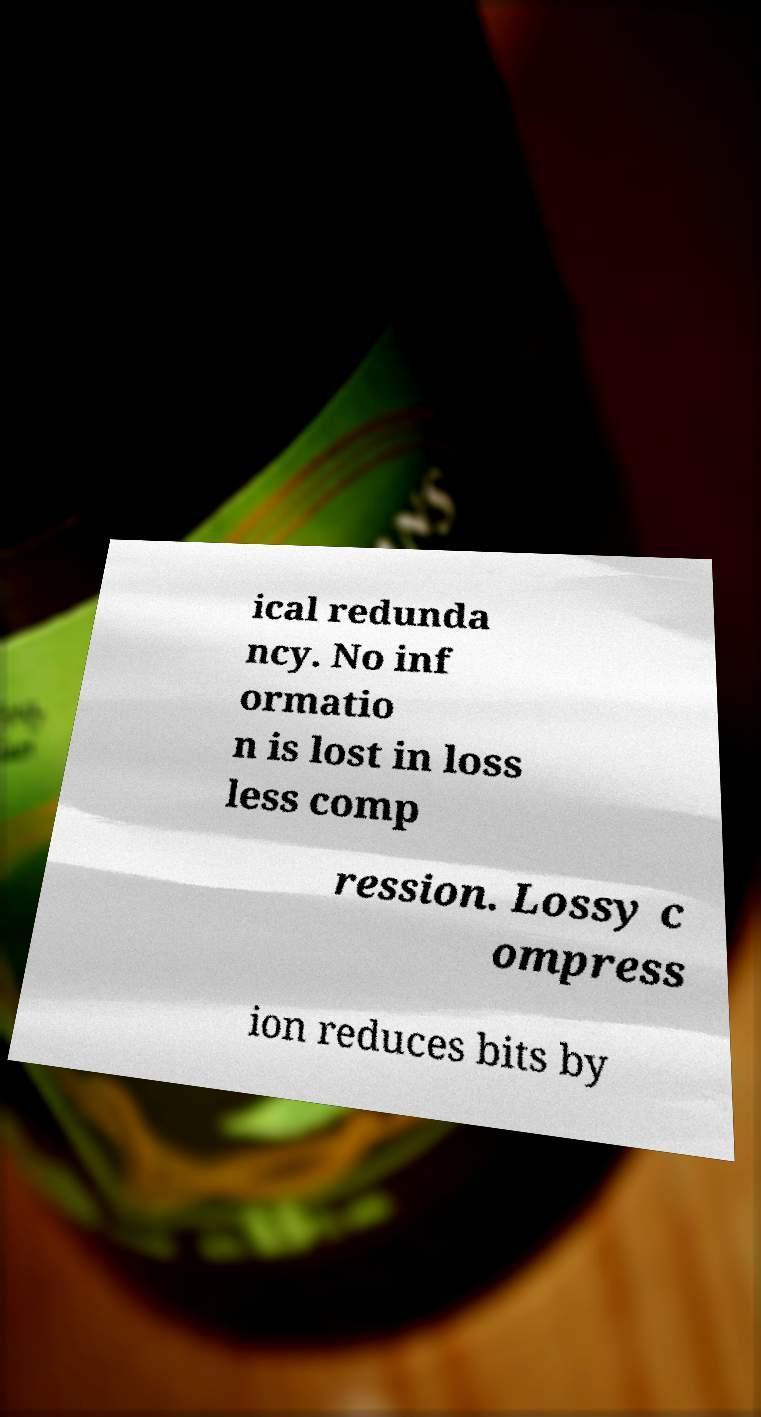Could you extract and type out the text from this image? ical redunda ncy. No inf ormatio n is lost in loss less comp ression. Lossy c ompress ion reduces bits by 